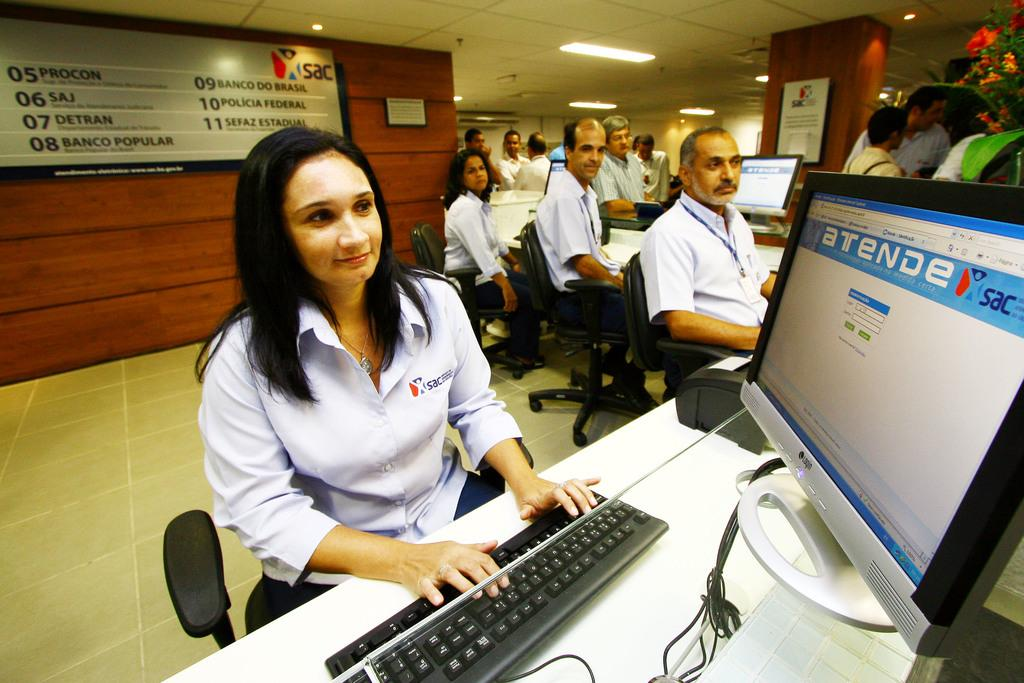<image>
Relay a brief, clear account of the picture shown. A woman who for works at SAC is working on her computer in an office with colleagues 